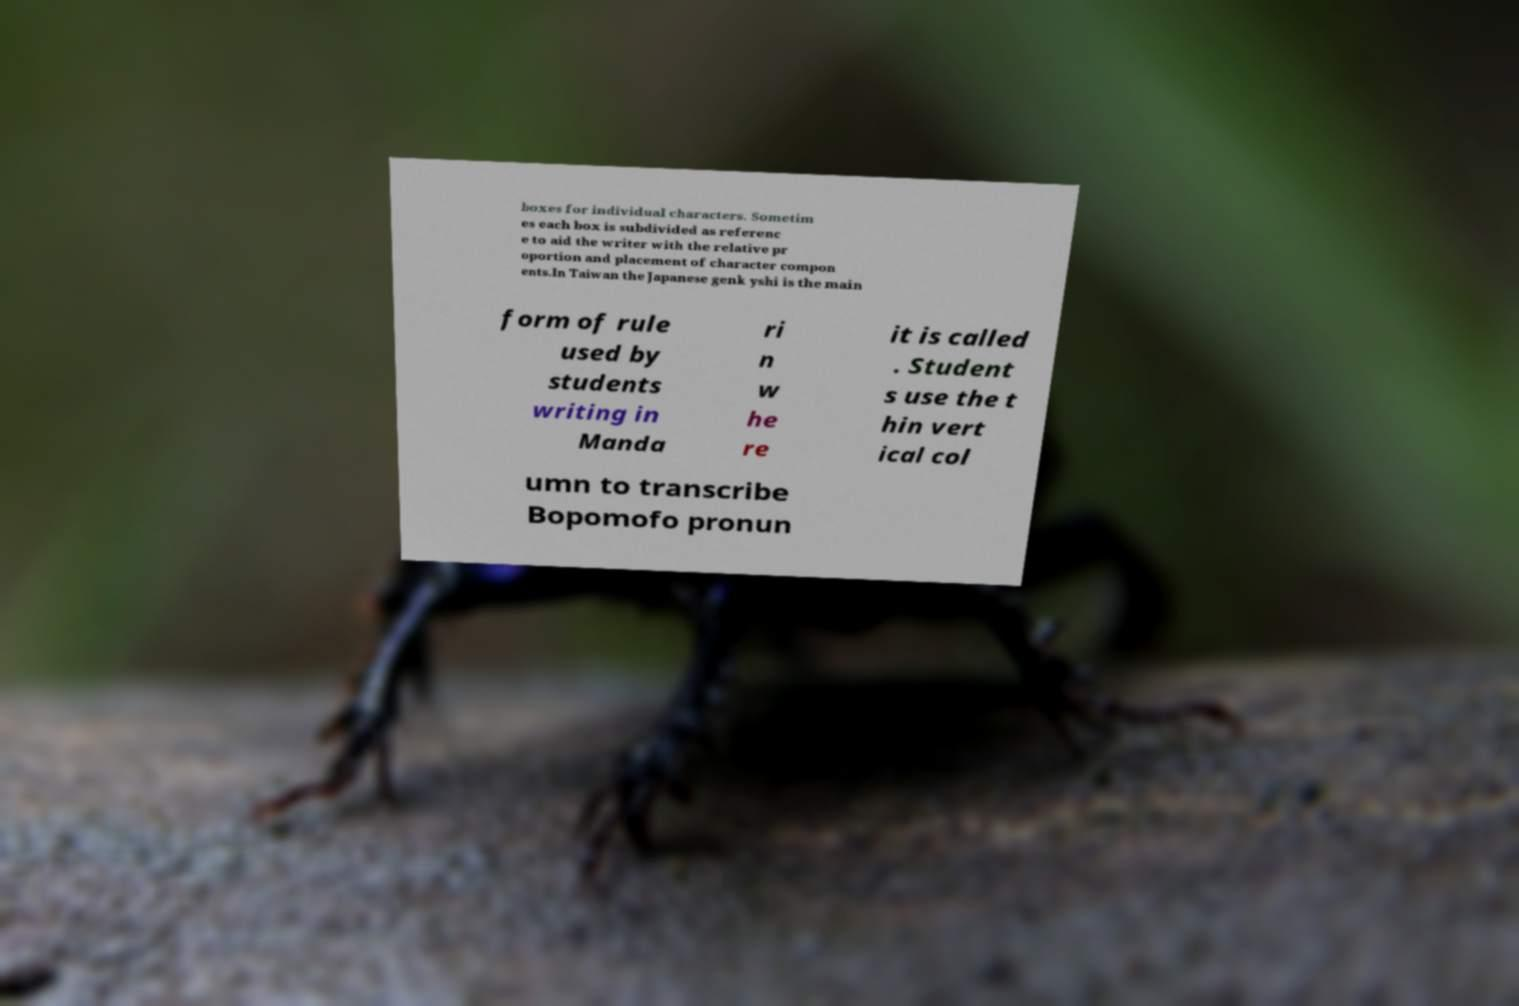Could you extract and type out the text from this image? boxes for individual characters. Sometim es each box is subdivided as referenc e to aid the writer with the relative pr oportion and placement of character compon ents.In Taiwan the Japanese genk yshi is the main form of rule used by students writing in Manda ri n w he re it is called . Student s use the t hin vert ical col umn to transcribe Bopomofo pronun 